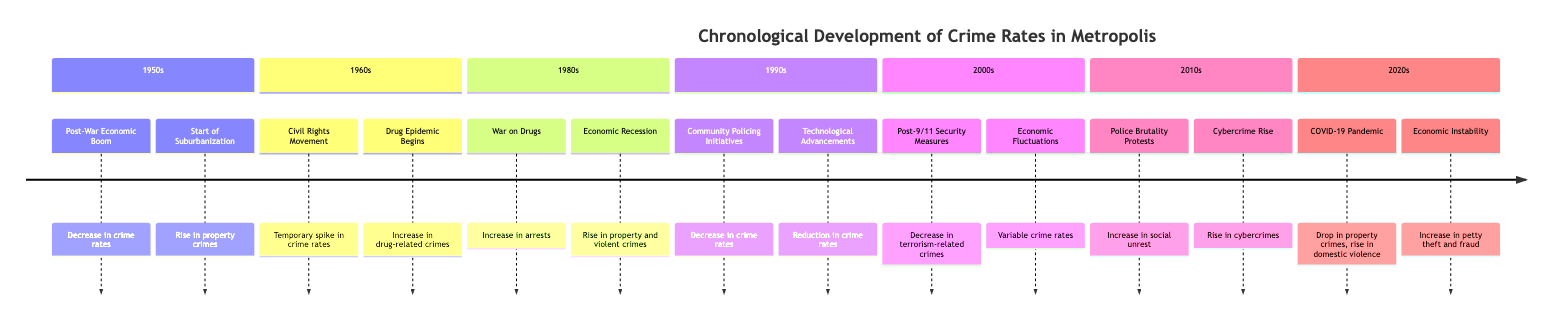What event in the 1960s caused a temporary spike in crime rates? The diagram shows that the "Civil Rights Movement" was an event in the 1960s that led to a "Temporary spike in crime rates due to social unrest."
Answer: Civil Rights Movement Which decade saw the introduction of community policing initiatives? According to the diagram, the event "Community Policing Initiatives" is listed in the 1990s section, indicating that this decade was when these initiatives were introduced.
Answer: 1990s How many events are listed for the 1980s? The diagram has two events listed under the 1980s: "War on Drugs" and "Economic Recession." Therefore, there are two events in total.
Answer: 2 What was the impact of the COVID-19 pandemic on property crimes? The diagram states that the "COVID-19 Pandemic" led to a "Temporary drop in property crimes" during the 2020s, outlining its specific impact.
Answer: Drop Which event in the 2000s specifically targeted terrorism-related crimes? From the diagram, "Post-9/11 Security Measures" in the 2000s focused on "Decrease in terrorism-related crimes," making it the relevant event.
Answer: Post-9/11 Security Measures During which decade did drug-related crimes increase due to a drug epidemic? The diagram indicates that the "Drug Epidemic Begins" was a key event in the 1960s, which caused an "Increase in drug-related crimes and violence."
Answer: 1960s What was the impact of technological advancements on crime rates in the 1990s? Referring to the diagram, "Technological Advancements" in the 1990s resulted in a "Reduction in crime rates due to proactive policing," illustrating its positive impact.
Answer: Reduction When did police brutality protests lead to an increase in social unrest? The diagram lists "Police Brutality Protests" as an event in the 2010s, leading to an "Increase in social unrest and crime spikes during protests."
Answer: 2010s In what decade did economic instability affect petty theft and fraud rates? The diagram shows that "Economic Instability" was an event in the 2020s, which caused an "Increase in certain types of crimes, including petty theft and fraud."
Answer: 2020s What societal movement in the 1960s was tied to increased drug-related crimes? The diagram connects the "Civil Rights Movement" with a temporary spike in crime rates, but the "Drug Epidemic Begins" is the event directly linked to increased drug-related crimes in that decade.
Answer: Drug Epidemic Begins 